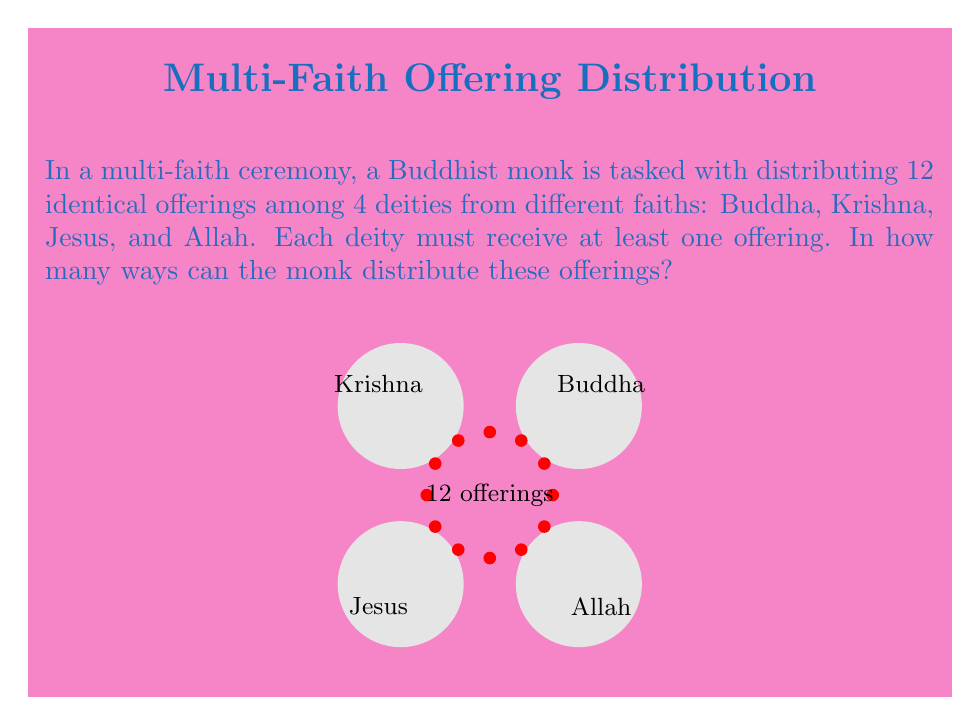Could you help me with this problem? Let's approach this step-by-step using the concept of stars and bars (also known as balls and urns):

1) We have 12 identical offerings (stars) and 4 deities (bars).

2) Each deity must receive at least one offering, so we start by giving one offering to each deity. This leaves us with 8 offerings to distribute.

3) Now, we need to find the number of ways to distribute 8 identical objects among 4 distinct groups, which is equivalent to placing 8 stars in the spaces created by 3 bars.

4) The formula for this scenario is:

   $${n+k-1 \choose k-1}$$

   Where $n$ is the number of identical objects (remaining offerings) and $k$ is the number of distinct groups (deities).

5) In this case, $n = 8$ and $k = 4$. So we have:

   $${8+4-1 \choose 4-1} = {11 \choose 3}$$

6) We can calculate this:

   $${11 \choose 3} = \frac{11!}{3!(11-3)!} = \frac{11!}{3!8!} = \frac{11 \cdot 10 \cdot 9}{3 \cdot 2 \cdot 1} = 165$$

Therefore, there are 165 ways for the Buddhist monk to distribute the offerings among the four deities in this multi-faith ceremony.
Answer: 165 